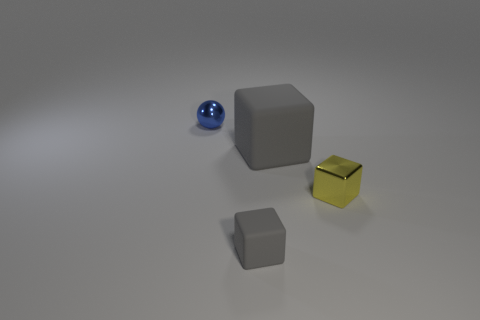Are there any shiny blocks of the same color as the ball?
Provide a succinct answer. No. Is the size of the cube in front of the yellow block the same as the tiny blue shiny sphere?
Your answer should be compact. Yes. Is the number of metal spheres less than the number of gray matte things?
Give a very brief answer. Yes. Are there any big brown things made of the same material as the yellow cube?
Keep it short and to the point. No. The object that is to the right of the big object has what shape?
Give a very brief answer. Cube. There is a rubber object that is behind the tiny gray rubber thing; is it the same color as the small metallic cube?
Your answer should be compact. No. Are there fewer tiny things in front of the metallic sphere than tiny yellow metallic spheres?
Your answer should be compact. No. What color is the other small thing that is the same material as the small yellow thing?
Provide a succinct answer. Blue. There is a gray matte object that is in front of the tiny yellow cube; what is its size?
Provide a short and direct response. Small. Are the small ball and the big gray block made of the same material?
Provide a short and direct response. No. 